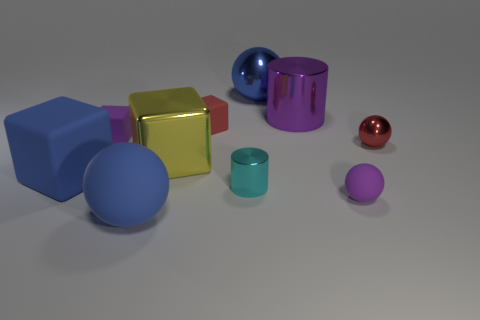How many yellow metallic blocks are there? 1 